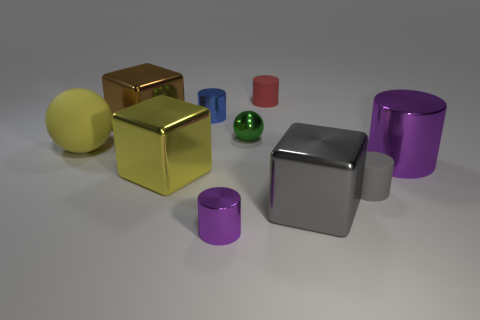How would you describe the scene depicted in this image? The scene is a simple composition of various geometric shapes with different textures and colors, arranged on a plain surface against a non-descript background. It conveys a minimalist aesthetic, often used to illustrate concepts in geometry, physics, or graphical rendering. What could these objects represent in a symbolic way? Symbolically, the diverse shapes and colors could represent diversity and individuality, standing out in their own space yet creating harmony as a collective. One might interpret this arrangement as a metaphor for societal diversity or a visual representation of the variety found in nature. 